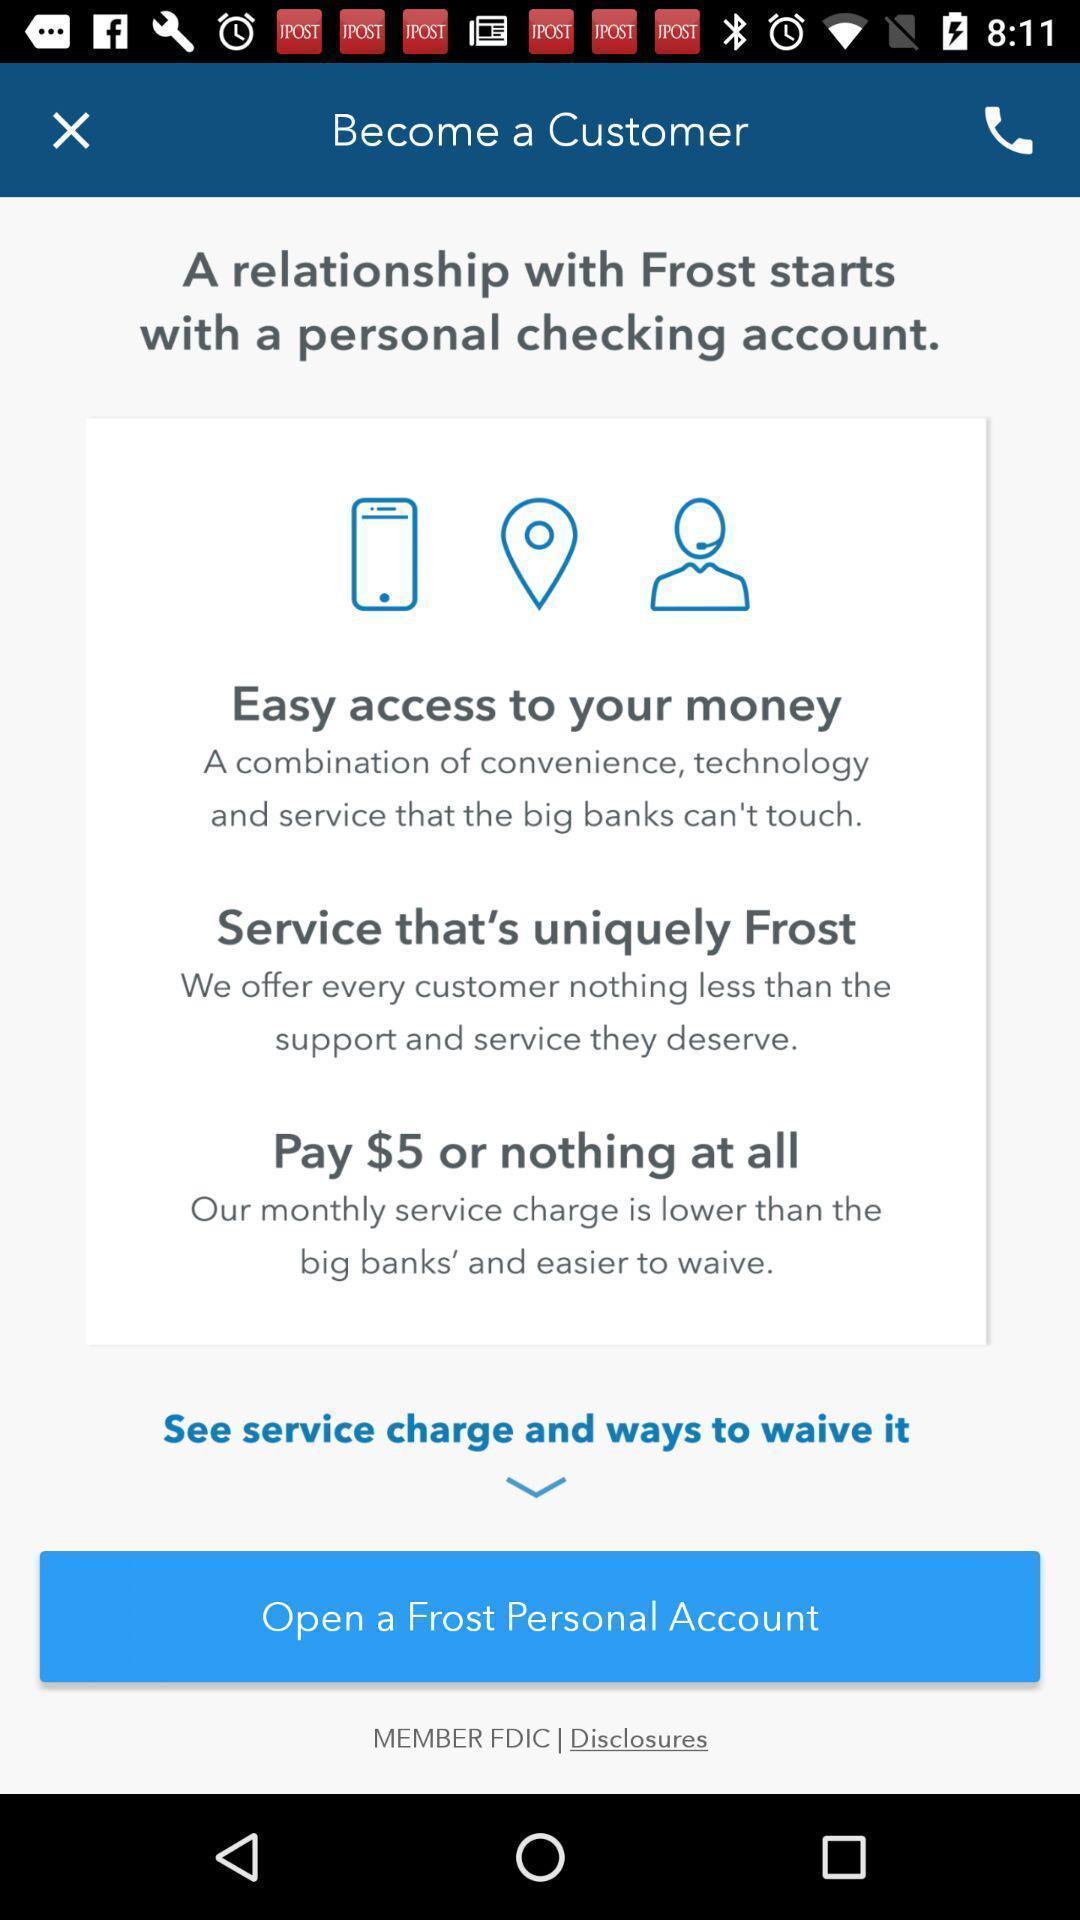Tell me about the visual elements in this screen capture. Welcome page of a financial app. 